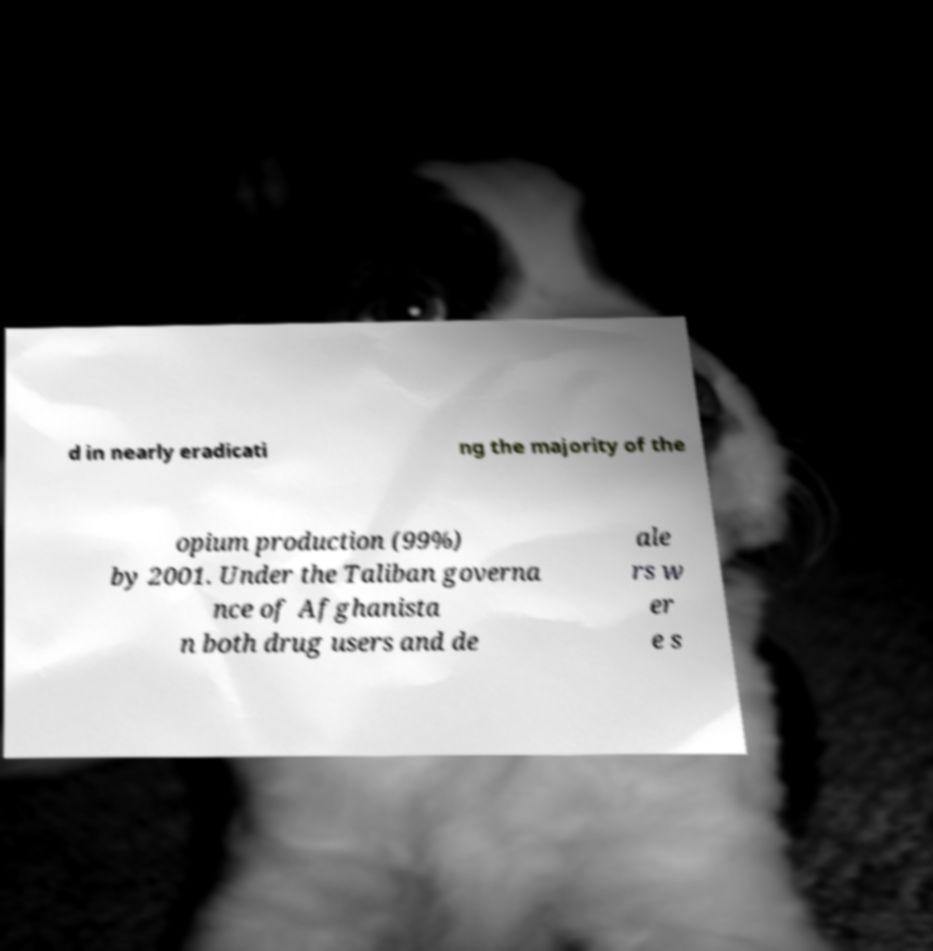Could you assist in decoding the text presented in this image and type it out clearly? d in nearly eradicati ng the majority of the opium production (99%) by 2001. Under the Taliban governa nce of Afghanista n both drug users and de ale rs w er e s 